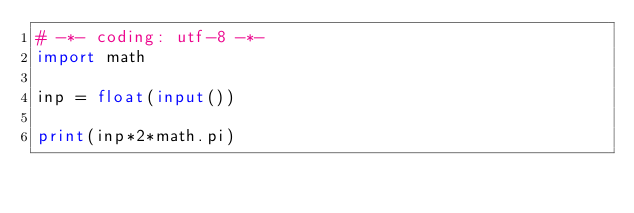<code> <loc_0><loc_0><loc_500><loc_500><_Python_># -*- coding: utf-8 -*-
import math
 
inp = float(input())
 
print(inp*2*math.pi)</code> 